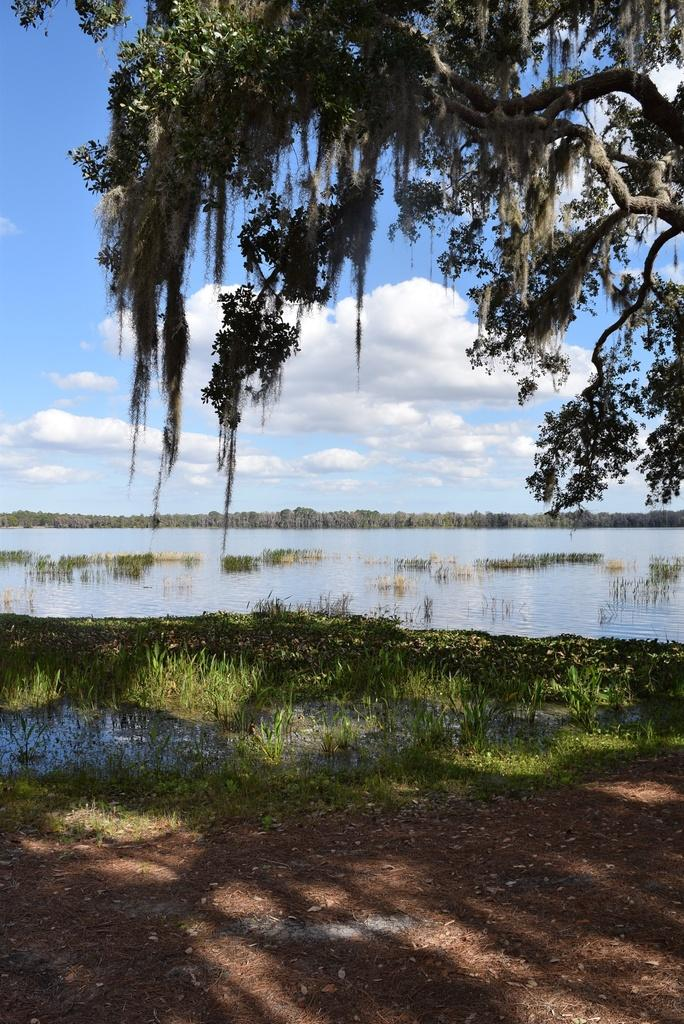What type of natural feature is present in the image? There is a river in the image. What is unusual about the water in the image? There is grass in the water. What type of vegetation is present on the ground? There is grass on the ground. What other objects can be seen on the ground? There are dried leaves and trees on the ground. What is visible at the top of the image? The sky is visible at the top of the image. What theory is being proposed by the birds in the image? There are no birds present in the image, so no theory can be proposed by them. What type of harmony is being depicted in the image? The image does not depict any harmony; it shows a river, grass, dried leaves, trees, and the sky. 